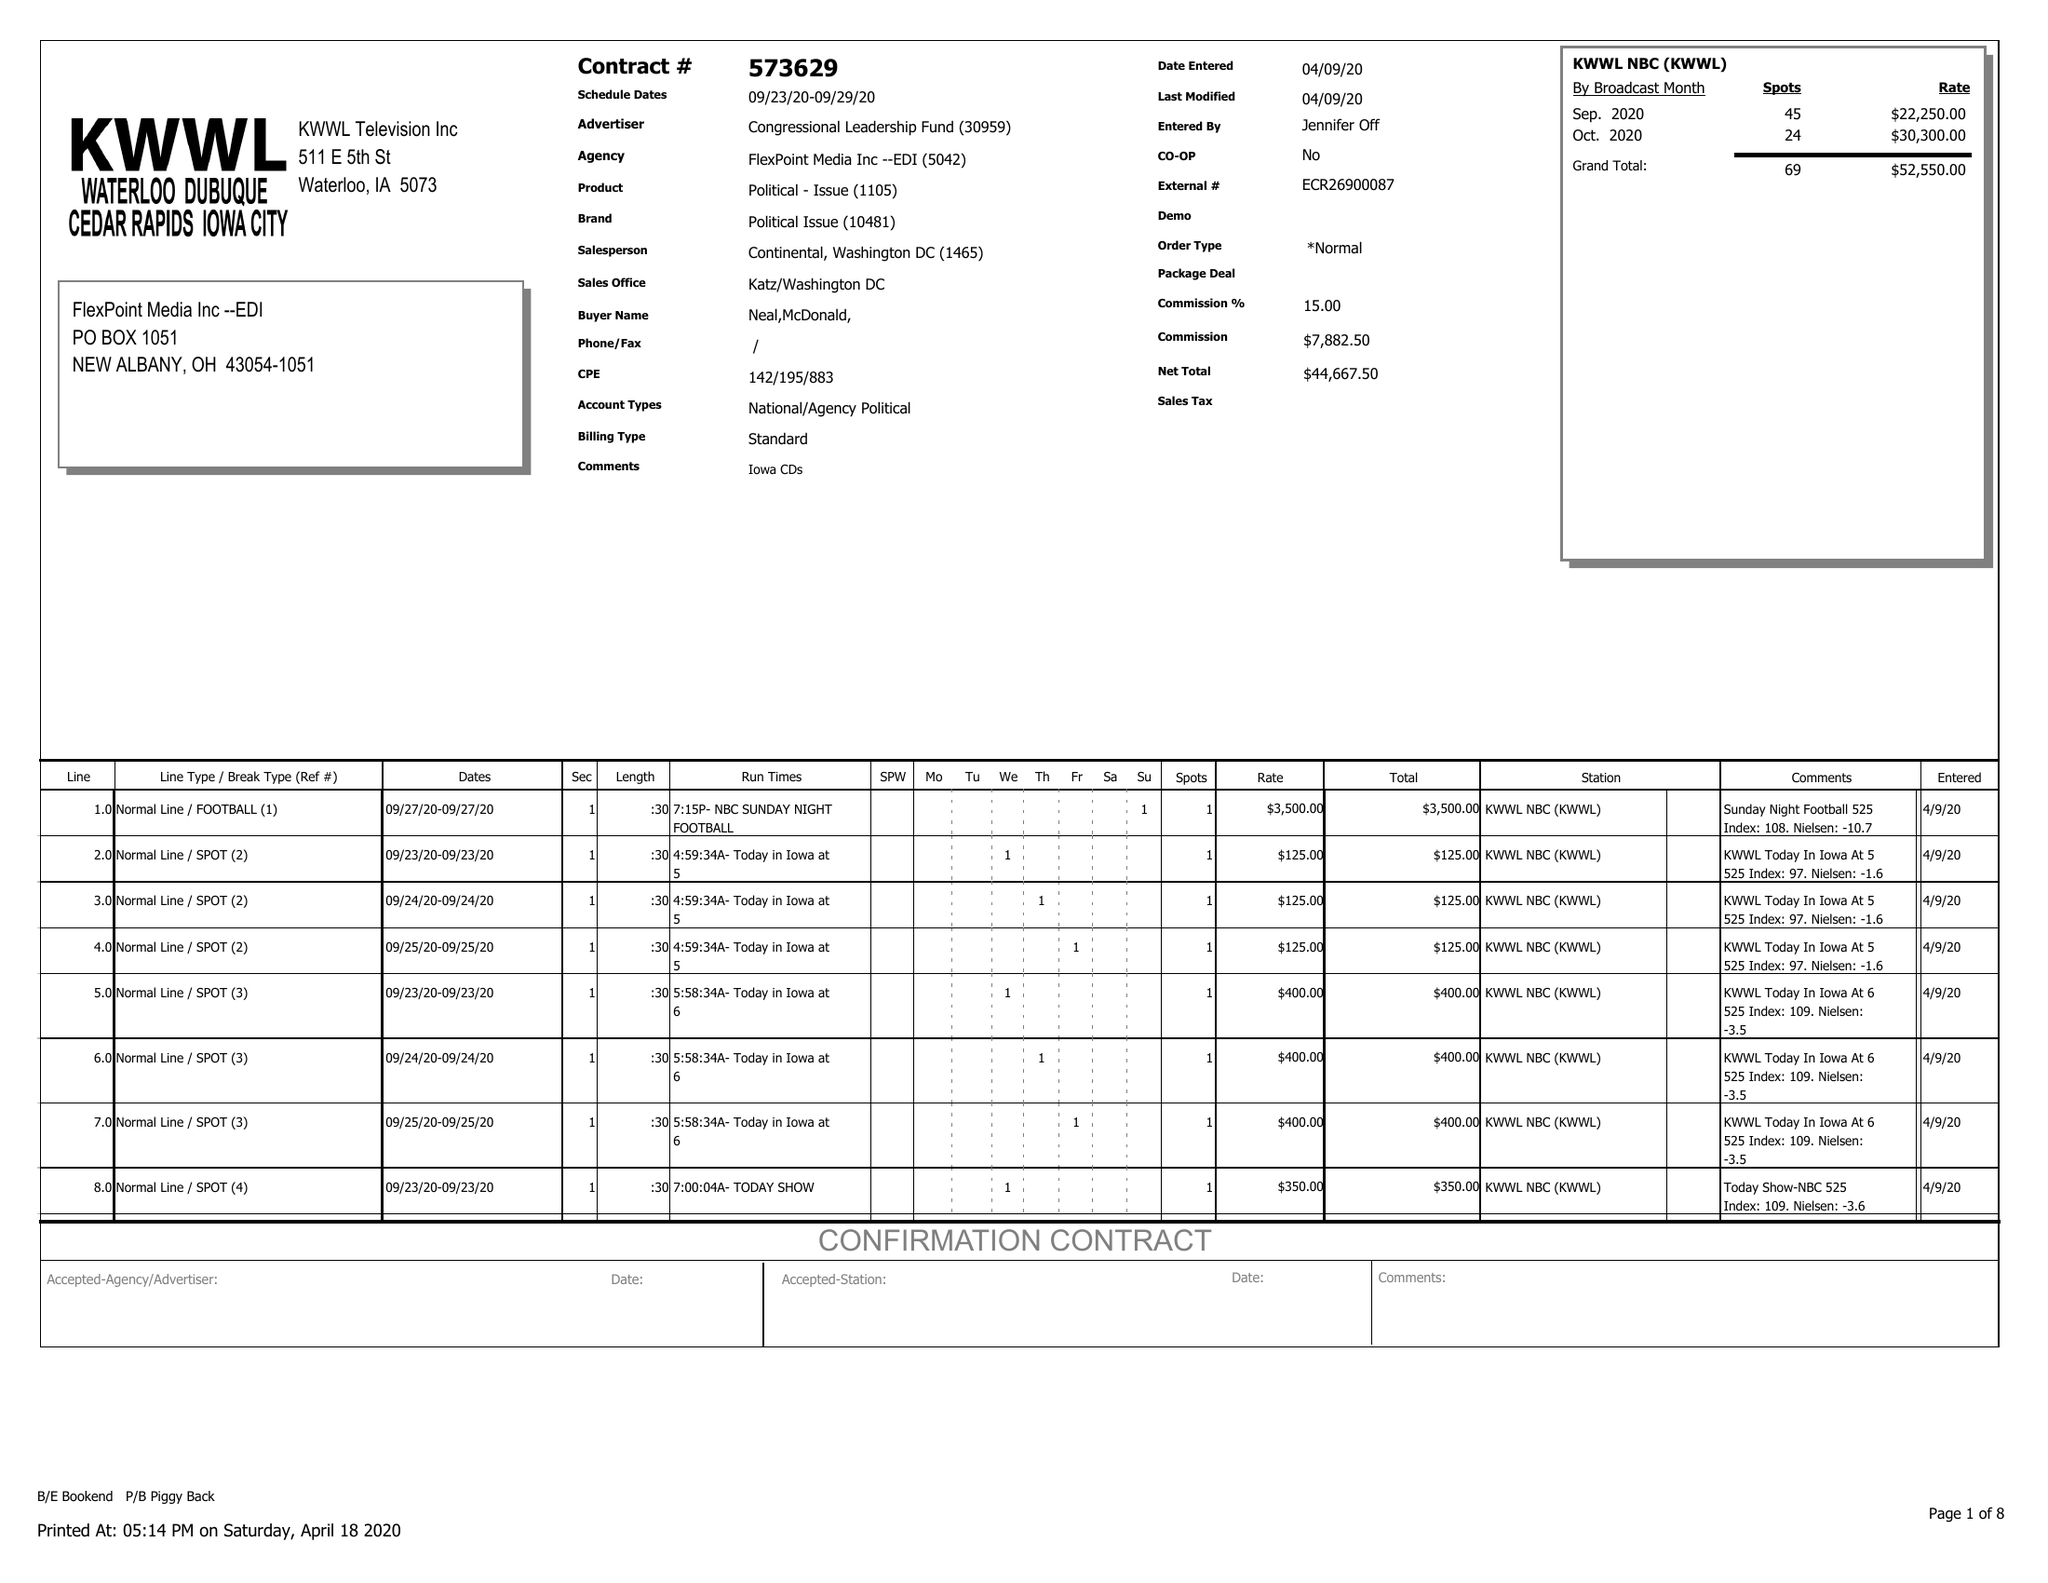What is the value for the flight_to?
Answer the question using a single word or phrase. 09/29/20 